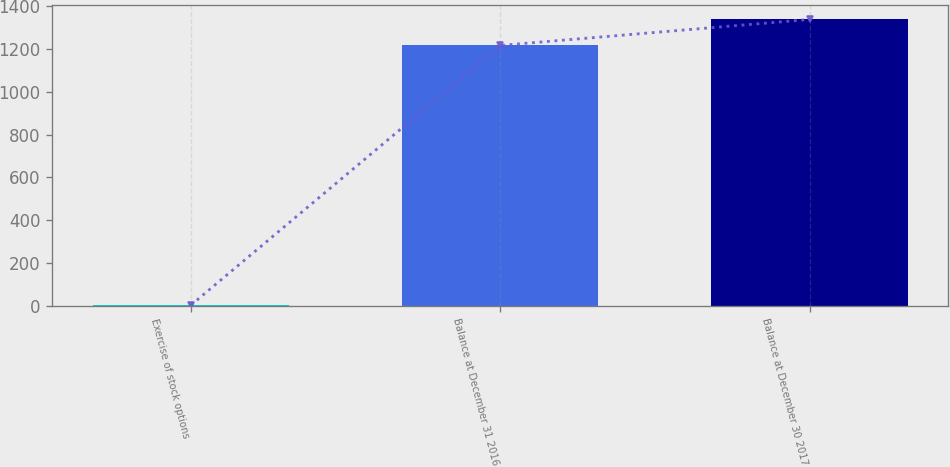Convert chart to OTSL. <chart><loc_0><loc_0><loc_500><loc_500><bar_chart><fcel>Exercise of stock options<fcel>Balance at December 31 2016<fcel>Balance at December 30 2017<nl><fcel>3<fcel>1217<fcel>1338.6<nl></chart> 